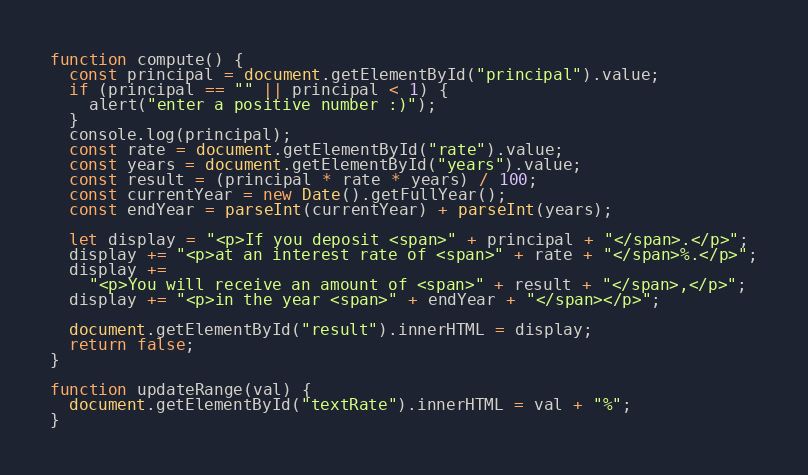<code> <loc_0><loc_0><loc_500><loc_500><_JavaScript_>function compute() {
  const principal = document.getElementById("principal").value;
  if (principal == "" || principal < 1) {
    alert("enter a positive number :)");
  }
  console.log(principal);
  const rate = document.getElementById("rate").value;
  const years = document.getElementById("years").value;
  const result = (principal * rate * years) / 100;
  const currentYear = new Date().getFullYear();
  const endYear = parseInt(currentYear) + parseInt(years);

  let display = "<p>If you deposit <span>" + principal + "</span>.</p>";
  display += "<p>at an interest rate of <span>" + rate + "</span>%.</p>";
  display +=
    "<p>You will receive an amount of <span>" + result + "</span>,</p>";
  display += "<p>in the year <span>" + endYear + "</span></p>";

  document.getElementById("result").innerHTML = display;
  return false;
}

function updateRange(val) {
  document.getElementById("textRate").innerHTML = val + "%";
}
</code> 